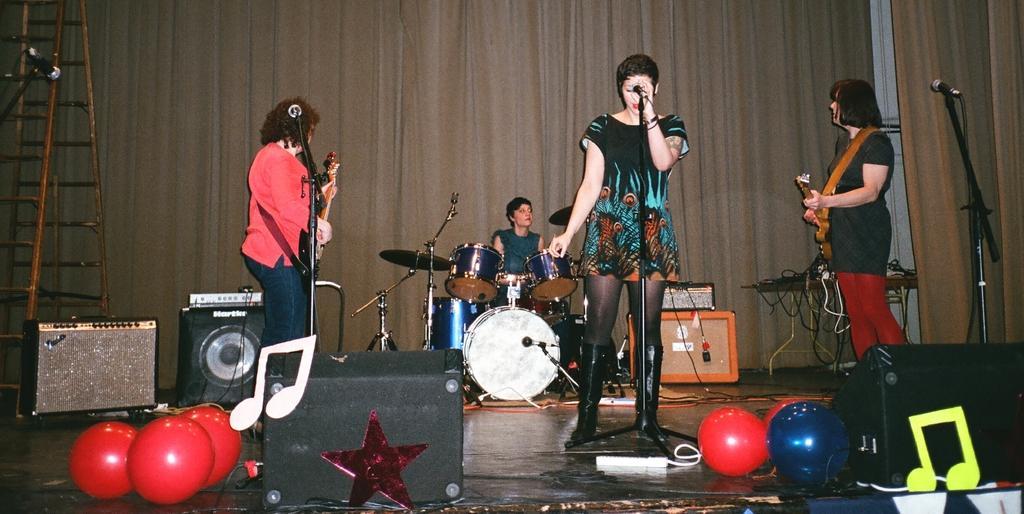How would you summarize this image in a sentence or two? In this picture we can see group of people these are all musicians in front of them we can find musical instruments, microphones, sound systems and balloons. 